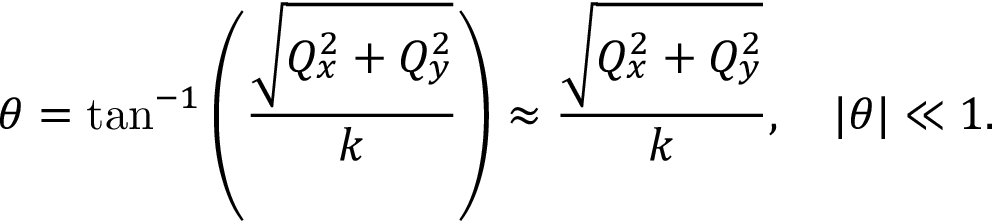<formula> <loc_0><loc_0><loc_500><loc_500>\theta = \tan ^ { - 1 } \left ( \frac { \sqrt { Q _ { x } ^ { 2 } + Q _ { y } ^ { 2 } } } { k } \right ) \approx \frac { \sqrt { Q _ { x } ^ { 2 } + Q _ { y } ^ { 2 } } } { k } , \quad | \theta | \ll 1 .</formula> 